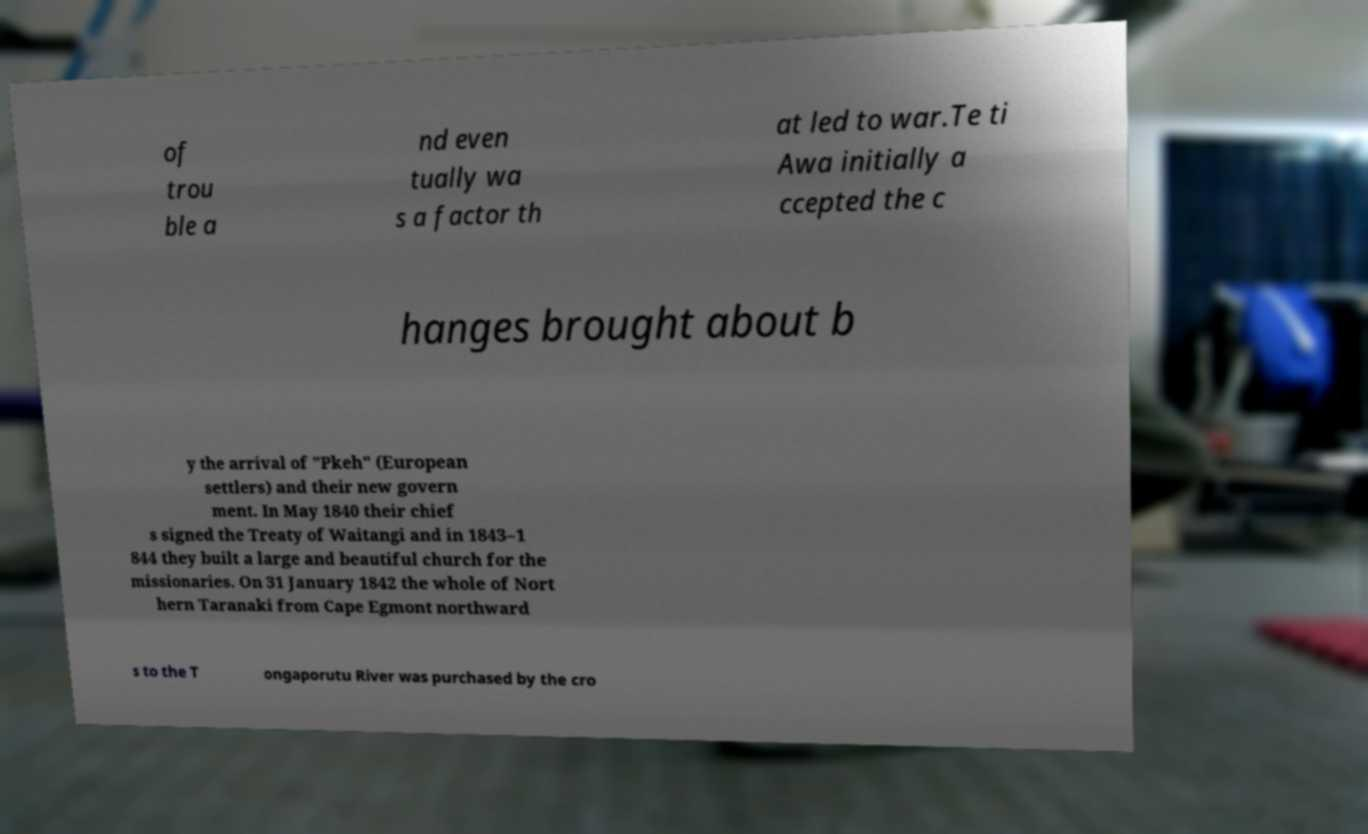What messages or text are displayed in this image? I need them in a readable, typed format. of trou ble a nd even tually wa s a factor th at led to war.Te ti Awa initially a ccepted the c hanges brought about b y the arrival of "Pkeh" (European settlers) and their new govern ment. In May 1840 their chief s signed the Treaty of Waitangi and in 1843–1 844 they built a large and beautiful church for the missionaries. On 31 January 1842 the whole of Nort hern Taranaki from Cape Egmont northward s to the T ongaporutu River was purchased by the cro 